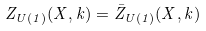Convert formula to latex. <formula><loc_0><loc_0><loc_500><loc_500>Z _ { U ( 1 ) } ( X , k ) = \bar { Z } _ { U ( 1 ) } ( X , k )</formula> 